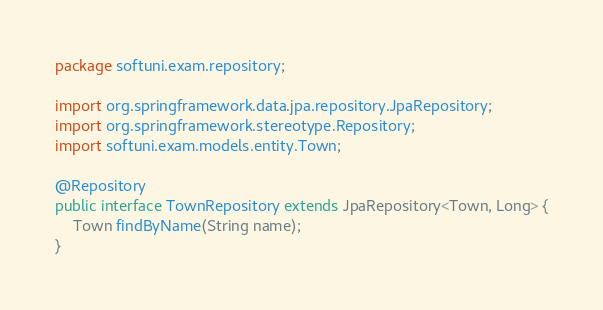Convert code to text. <code><loc_0><loc_0><loc_500><loc_500><_Java_>package softuni.exam.repository;

import org.springframework.data.jpa.repository.JpaRepository;
import org.springframework.stereotype.Repository;
import softuni.exam.models.entity.Town;

@Repository
public interface TownRepository extends JpaRepository<Town, Long> {
    Town findByName(String name);
}
</code> 